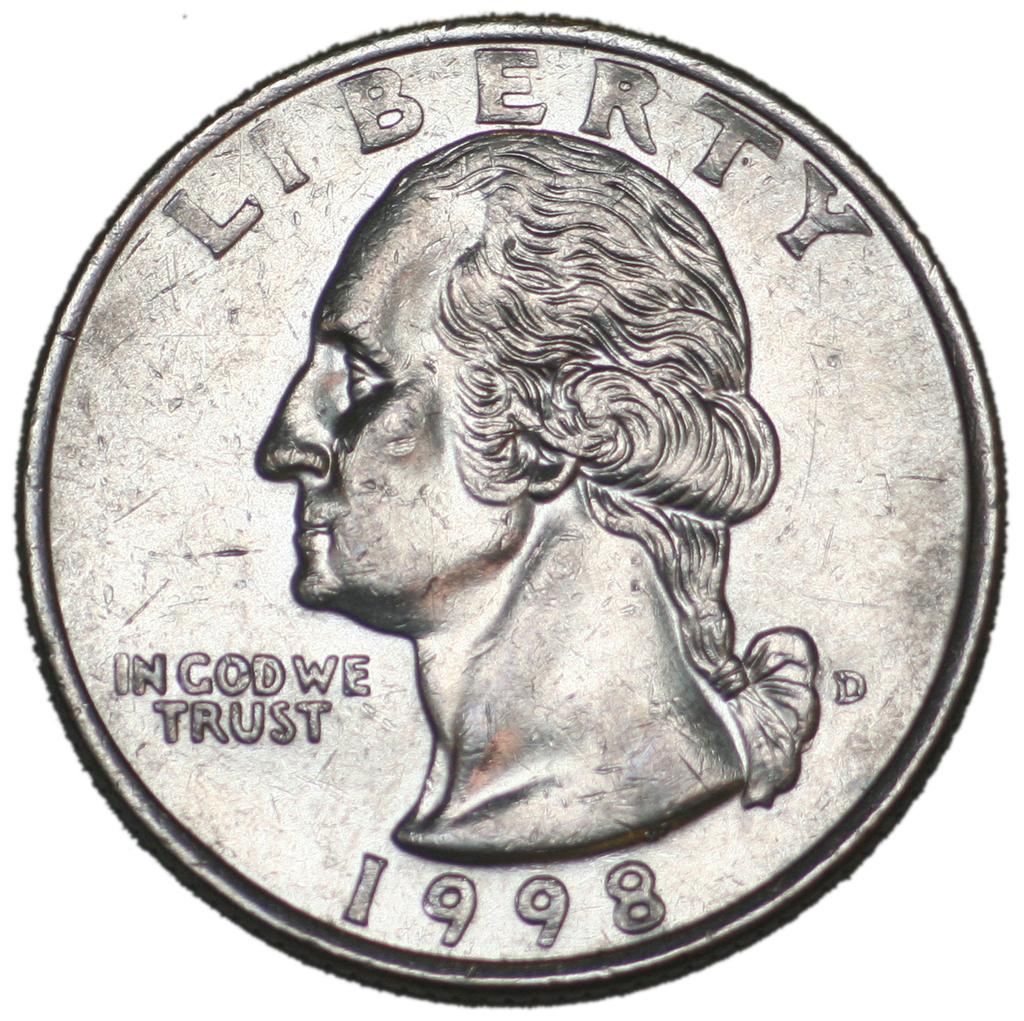<image>
Render a clear and concise summary of the photo. a silver liberty quarter from 1998 equals 25 cents 